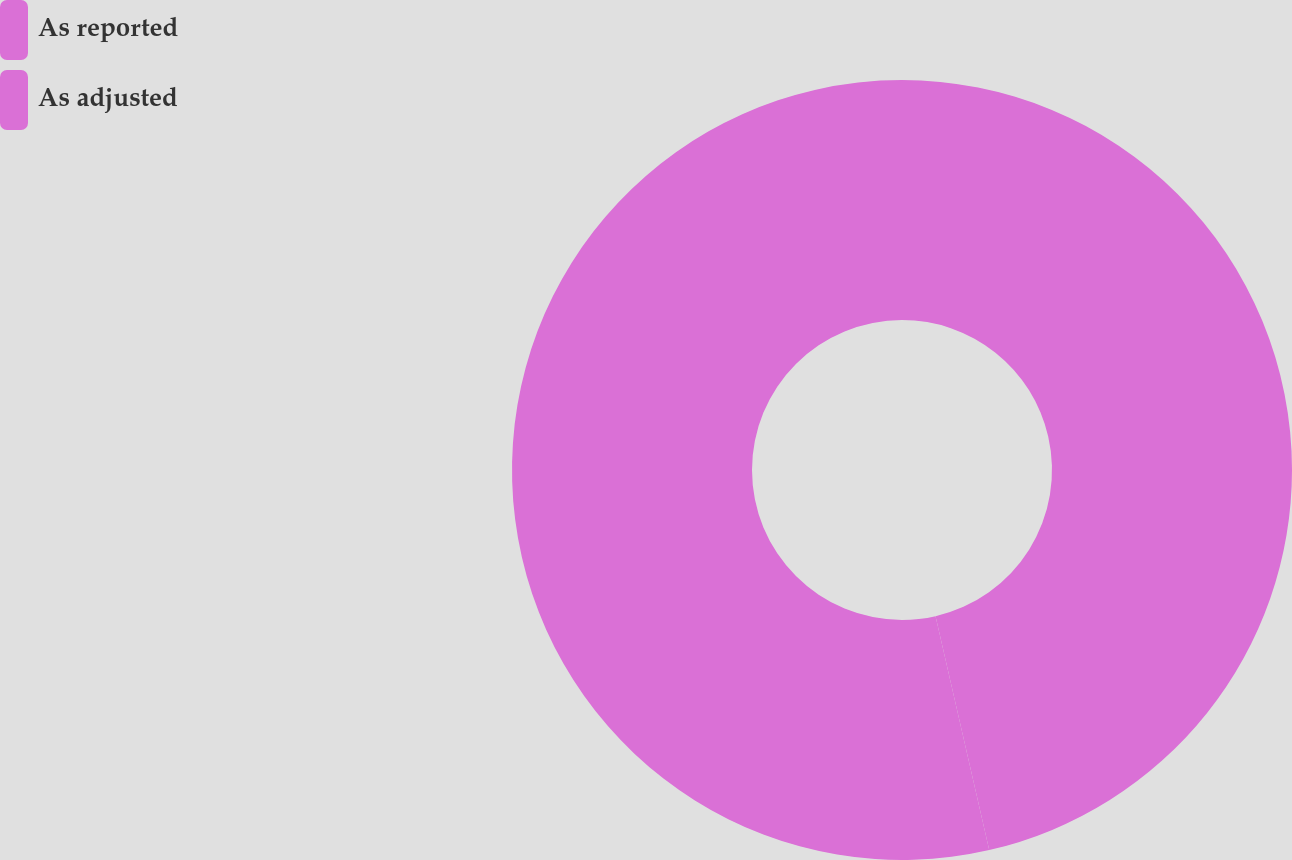<chart> <loc_0><loc_0><loc_500><loc_500><pie_chart><fcel>As reported<fcel>As adjusted<nl><fcel>46.41%<fcel>53.59%<nl></chart> 